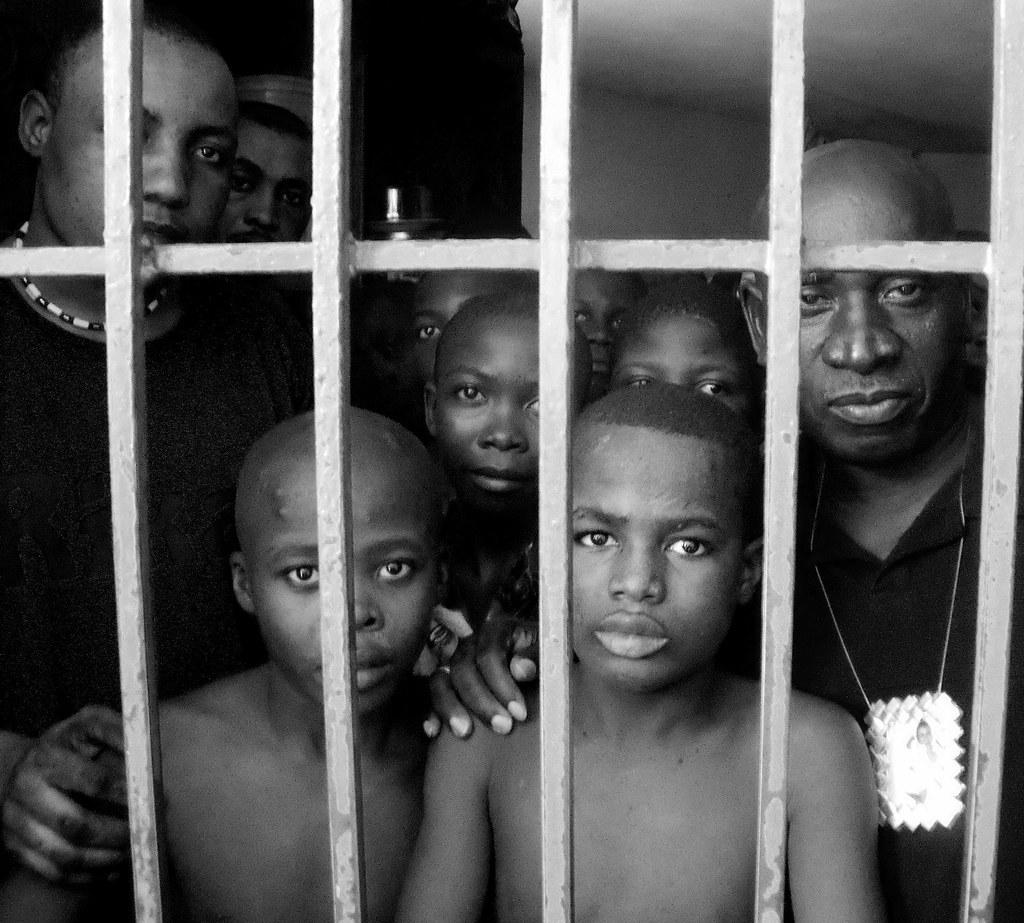What is the color scheme of the image? The image is black and white. What can be seen in the image besides the color scheme? There are people and a grille in the image. How would you describe the background of the image? The background of the image is dark. What advice does the queen give to the people in the image? There is no queen present in the image, so it is not possible to answer that question. 